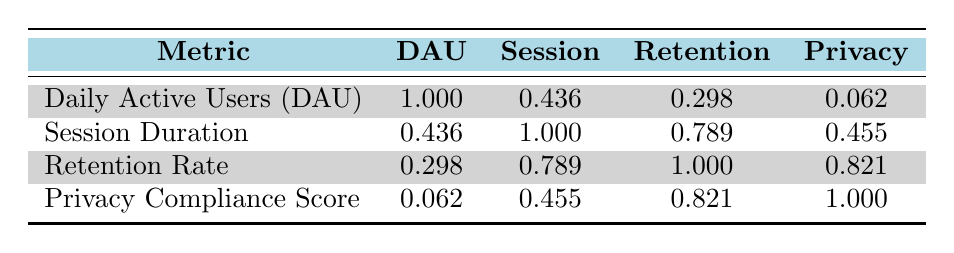What is the data privacy compliance score for FitTrack? The table lists FitTrack under "Privacy Compliance Score," and the value next to it is 85.
Answer: 85 What is the retention rate percentage for SocialShare? The retention rate percentage for SocialShare is displayed in the row of the app, which indicates a value of 50.
Answer: 50 What is the average session duration across all apps? Adding the session durations (45 + 30 + 25 + 35 + 50 + 20 + 40 + 55) gives a total of 300 minutes. Since there are 8 apps, the average is 300/8 = 37.5 minutes.
Answer: 37.5 Is there a correlation between daily active users and data privacy compliance score based on the table? The correlation value between daily active users and privacy compliance score is 0.062, which suggests a very weak correlation.
Answer: No Which app has the highest retention rate? By examining the retention rates listed, the highest is for FitTrack at 75 percent.
Answer: FitTrack What is the difference between the session duration of GameZone and HealthBuddy? The session duration for GameZone is 50 minutes and for HealthBuddy is 20 minutes. The difference is 50 - 20 = 30 minutes.
Answer: 30 minutes Does a higher data privacy compliance score generally correlate with a higher retention rate? The correlation value between privacy compliance score (1.000 being perfect) and retention rate is 0.821, indicating a strong positive correlation.
Answer: Yes What are the combined daily active users for the two apps with the lowest privacy compliance scores? The two apps with the lowest privacy compliance scores are SocialShare (55) and GameZone (65). Their daily active users are 20000 and 12000, respectively; combined, that is 20000 + 12000 = 32000.
Answer: 32000 What is the correlation between session duration and retention rate? The table shows a correlation value of 0.789 between session duration and retention rate, indicating a strong positive correlation.
Answer: 0.789 